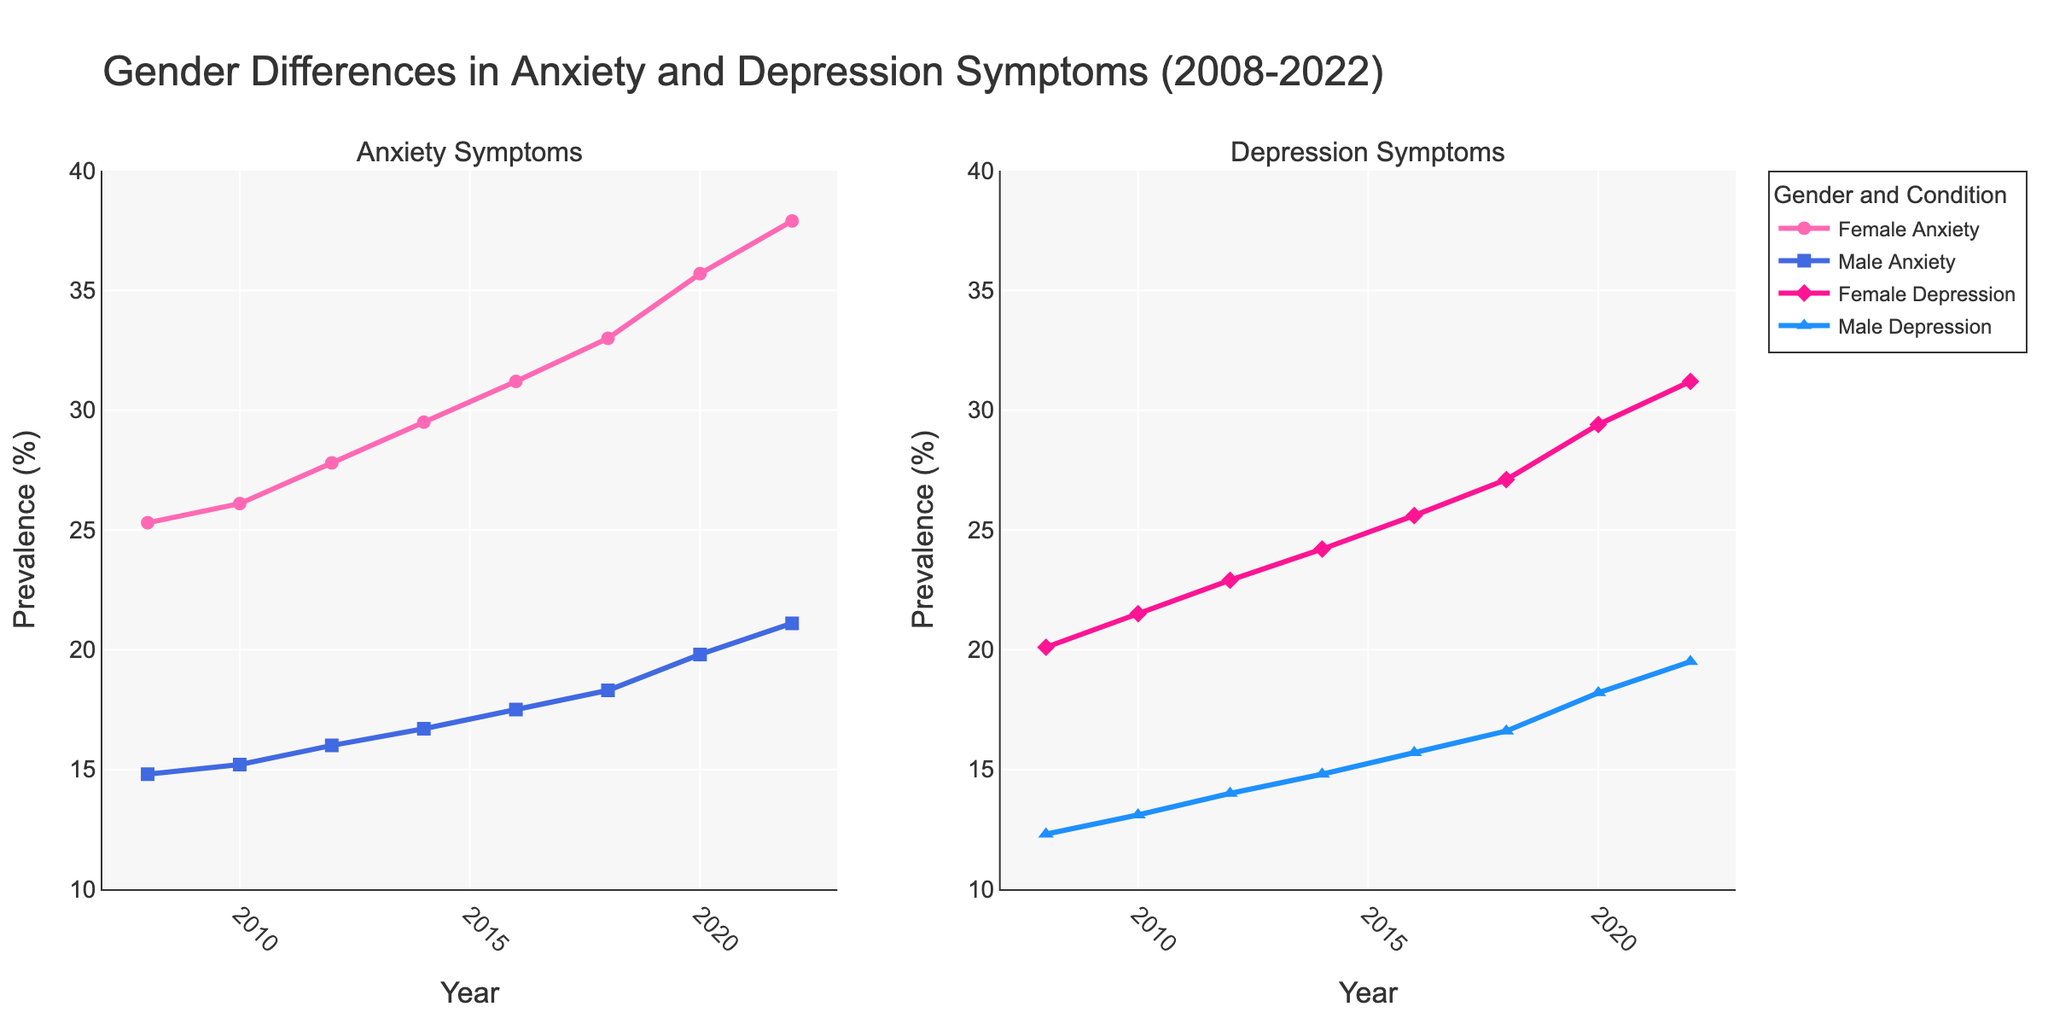What's the overall trend of female anxiety from 2008 to 2022? Observing the line chart for female anxiety from 2008 to 2022, there is a consistent upward trend. The prevalence increased each year starting from 25.3% in 2008 to 37.9% in 2022.
Answer: Increasing Which year saw the smallest difference between male and female depression rates? Look at the parallel lines for male and female depression and find the points where the gap is narrowest. In 2008, the difference is (20.1 - 12.3) = 7.8 percentage points, and no other year shows a smaller difference than this.
Answer: 2008 What is the average prevalence of male anxiety over the 15-year period? Sum the prevalence of male anxiety rates and divide by the number of data points: (14.8 + 15.2 + 16.0 + 16.7 + 17.5 + 18.3 + 19.8 + 21.1) / 8. The sum is 139.4, and the average is 139.4 / 8 = 17.425.
Answer: 17.425% Between 2014 and 2018, which gender saw the largest increase in depression rates? Calculate the difference in depression rates for both genders between 2014 and 2018. Female depression increased from 24.2% to 27.1%, a difference of 2.9%. Male depression increased from 14.8% to 16.6%, a difference of 1.8%.
Answer: Female What year had the highest prevalence of total diagnosed depression for both genders combined? Calculate the combined rates of depression for all years. The highest combined rate is in 2022 with (31.2% + 19.5%) = 50.7%. No other year surpasses this.
Answer: 2022 How much higher was the prevalence of female anxiety compared to male anxiety in 2022? Subtract male anxiety prevalence from female anxiety prevalence in 2022. 37.9% - 21.1% = 16.8%.
Answer: 16.8% Which year experienced the largest year-over-year increase in male anxiety? Calculate the year-over-year increases in male anxiety percentages. The largest increase occurred between 2018 and 2020, where the prevalence rose from 18.3% to 19.8%, a difference of 1.5%.
Answer: 2018 to 2020 What is the difference in female and male anxiety rates in 2008 and how does this compare to the difference in depression rates in the same year? For 2008, subtract male anxiety from female anxiety it is (25.3 - 14.8) = 10.5%. For depression in 2008, it is (20.1 - 12.3) = 7.8%. Compare both differences 10.5% and 7.8%.
Answer: 10.5% vs 7.8% 